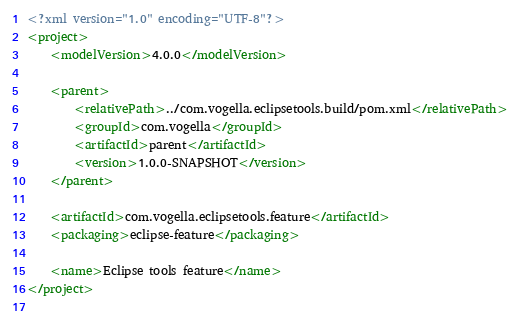<code> <loc_0><loc_0><loc_500><loc_500><_XML_><?xml version="1.0" encoding="UTF-8"?>
<project>
	<modelVersion>4.0.0</modelVersion>

	<parent>
		<relativePath>../com.vogella.eclipsetools.build/pom.xml</relativePath>
		<groupId>com.vogella</groupId>
		<artifactId>parent</artifactId>
		<version>1.0.0-SNAPSHOT</version>
	</parent>

	<artifactId>com.vogella.eclipsetools.feature</artifactId>
	<packaging>eclipse-feature</packaging>

	<name>Eclipse tools feature</name>
</project>
		</code> 